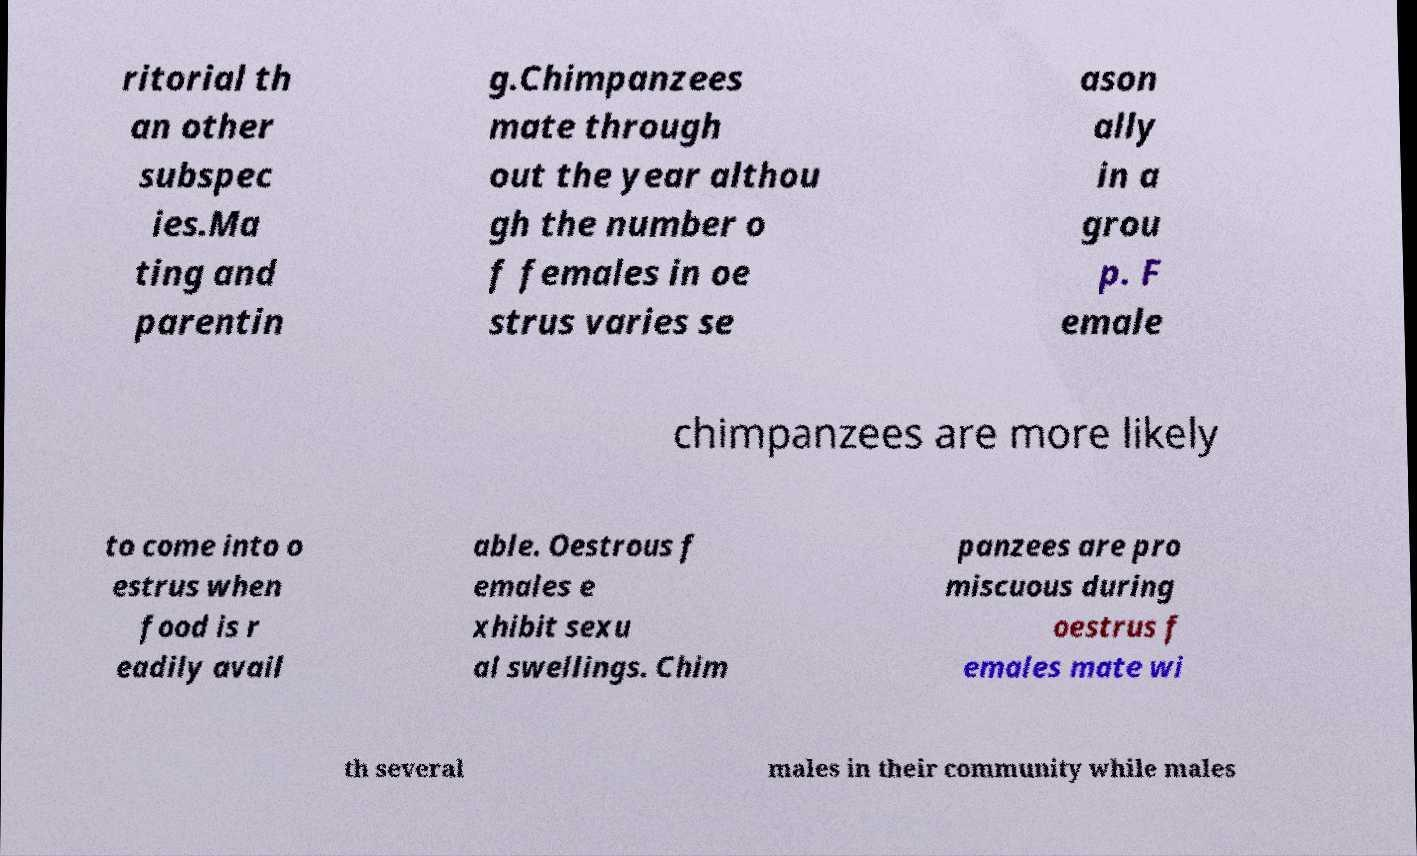Please identify and transcribe the text found in this image. ritorial th an other subspec ies.Ma ting and parentin g.Chimpanzees mate through out the year althou gh the number o f females in oe strus varies se ason ally in a grou p. F emale chimpanzees are more likely to come into o estrus when food is r eadily avail able. Oestrous f emales e xhibit sexu al swellings. Chim panzees are pro miscuous during oestrus f emales mate wi th several males in their community while males 